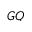<formula> <loc_0><loc_0><loc_500><loc_500>G Q</formula> 